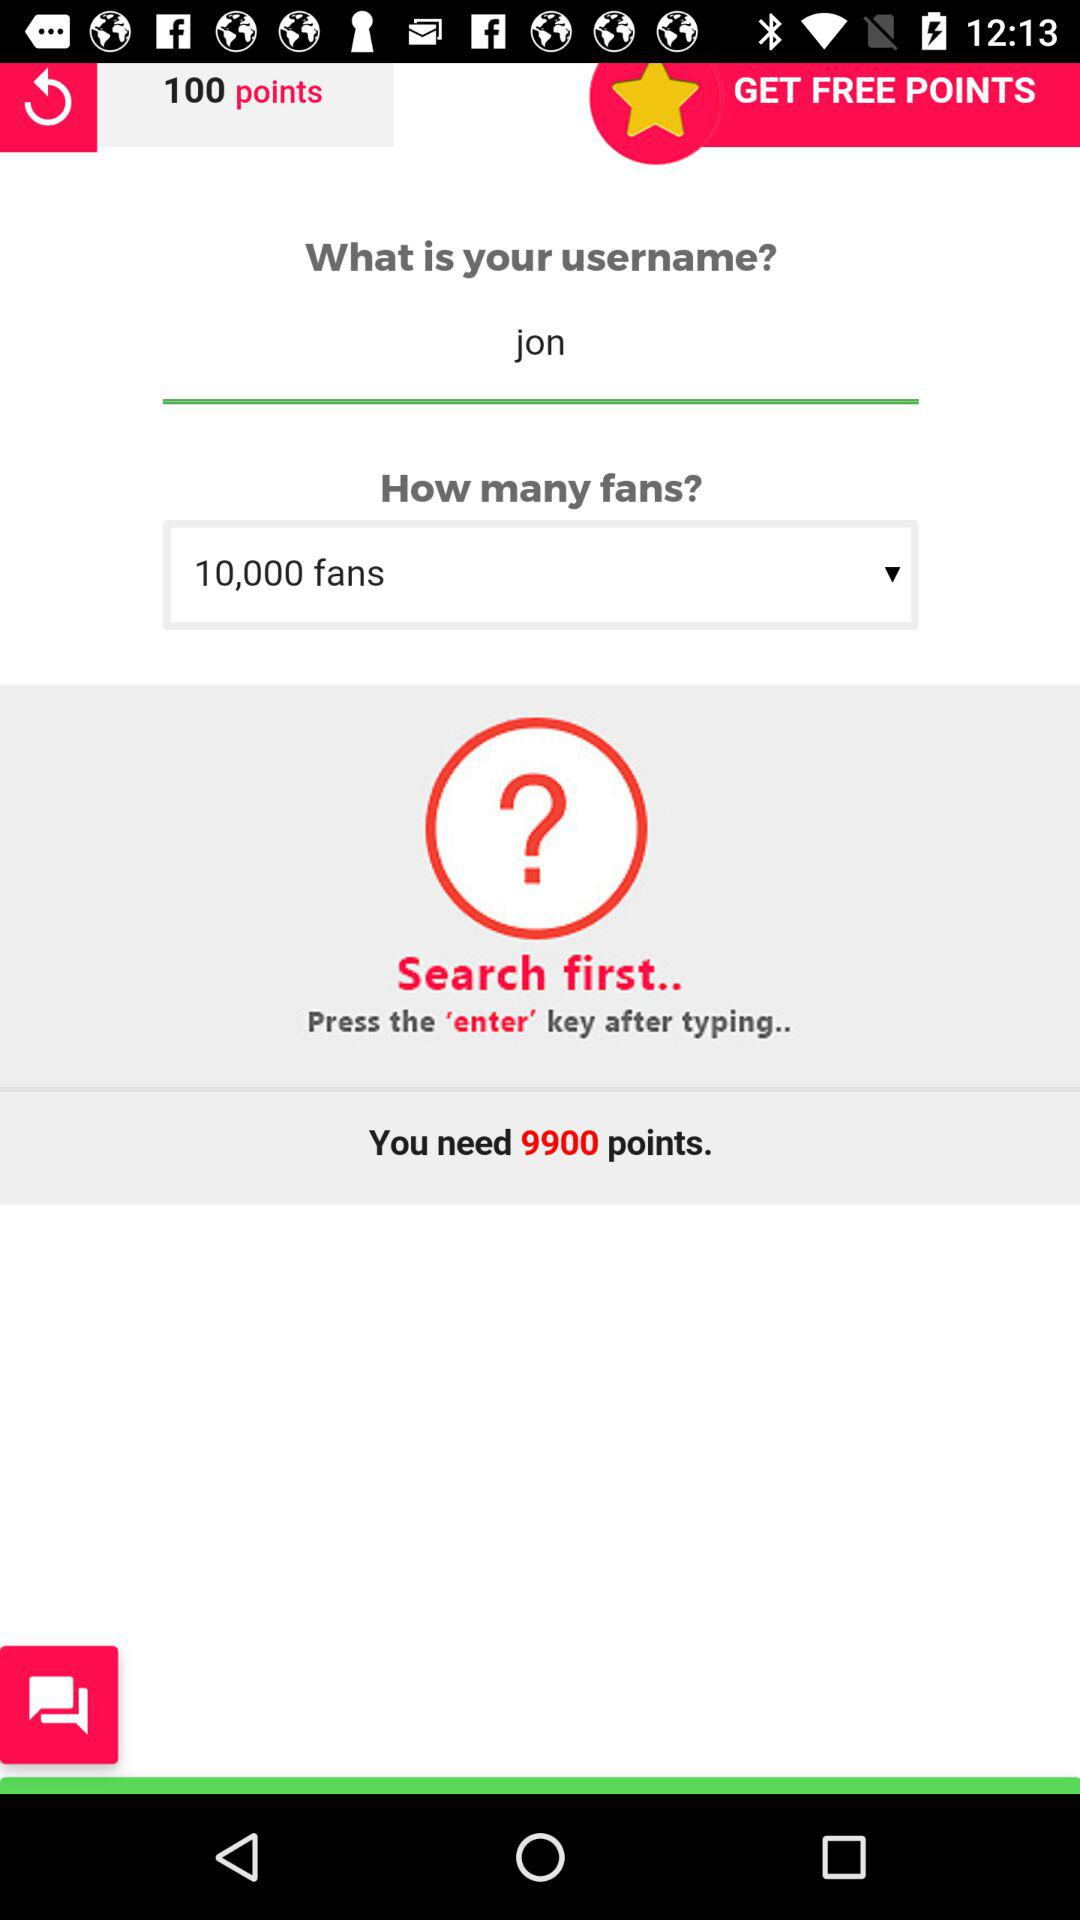How many points do we need? You need 9900 points. 